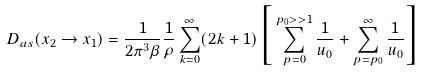<formula> <loc_0><loc_0><loc_500><loc_500>D _ { a s } ( x _ { 2 } \rightarrow x _ { 1 } ) = \frac { 1 } { 2 \pi ^ { 3 } \beta } \frac { 1 } { \rho } \sum _ { k = 0 } ^ { \infty } ( 2 k + 1 ) \Big { [ } \sum _ { p = 0 } ^ { p _ { 0 } > > 1 } \frac { 1 } { u _ { 0 } } + \sum _ { p = p _ { 0 } } ^ { \infty } \frac { 1 } { u _ { 0 } } \Big { ] }</formula> 